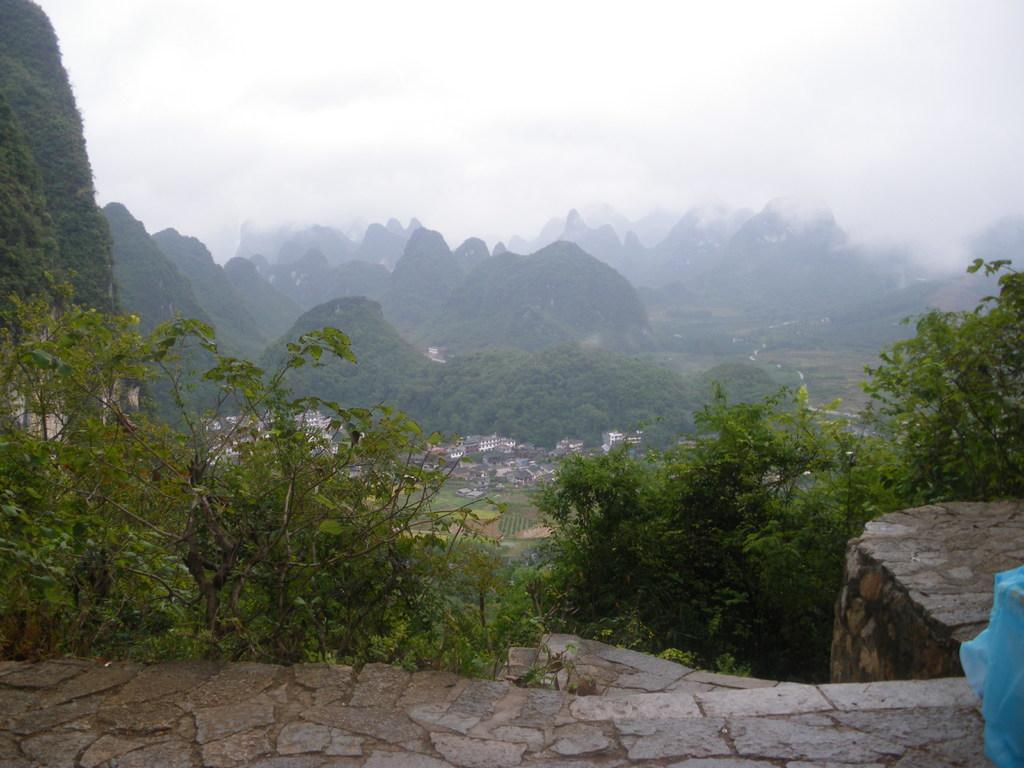What type of terrain is visible in the image? There are hills in the image. What type of vegetation can be seen in the image? There are trees in the image. Are there any man-made structures visible in the image? Yes, there are buildings in the image. What type of ground cover is present in the image? There is grass in the image. What type of surface is at the bottom of the image? There is pavement at the bottom of the image. What is visible at the top of the image? The sky is visible at the top of the image. Is there any weather condition present in the image? Yes, there is fog in the image. Where is the farm located in the image? There is no farm present in the image. What type of material is the cannon made of in the image? There is no cannon present in the image. What color is the marble in the image? There is no marble present in the image. 